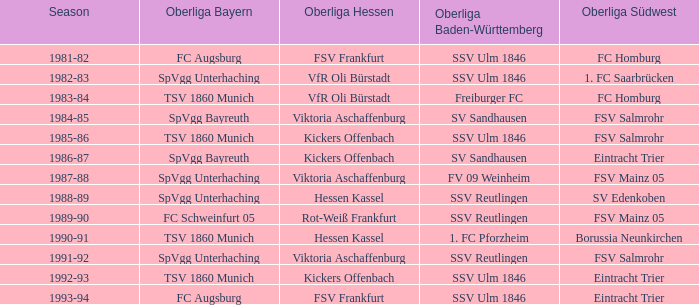During the 1991-92 season, which team was in the oberliga baden-württemberg? SSV Reutlingen. 